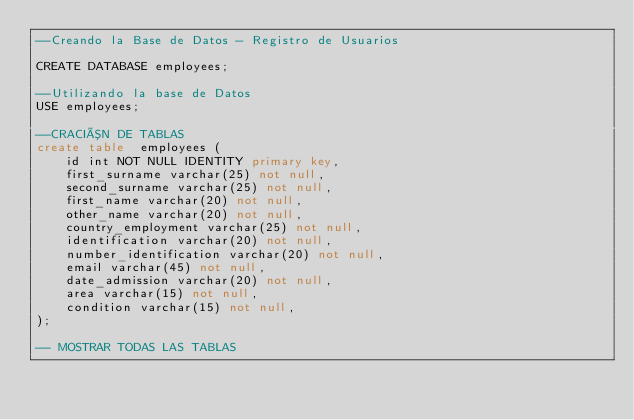<code> <loc_0><loc_0><loc_500><loc_500><_SQL_>--Creando la Base de Datos - Registro de Usuarios

CREATE DATABASE employees;

--Utilizando la base de Datos
USE employees;

--CRACIÓN DE TABLAS 
create table  employees (
    id int NOT NULL IDENTITY primary key,
    first_surname varchar(25) not null,
    second_surname varchar(25) not null,
    first_name varchar(20) not null,
    other_name varchar(20) not null,
    country_employment varchar(25) not null,
    identification varchar(20) not null,
    number_identification varchar(20) not null,
    email varchar(45) not null,
    date_admission varchar(20) not null,
    area varchar(15) not null,
    condition varchar(15) not null,
);

-- MOSTRAR TODAS LAS TABLAS
</code> 